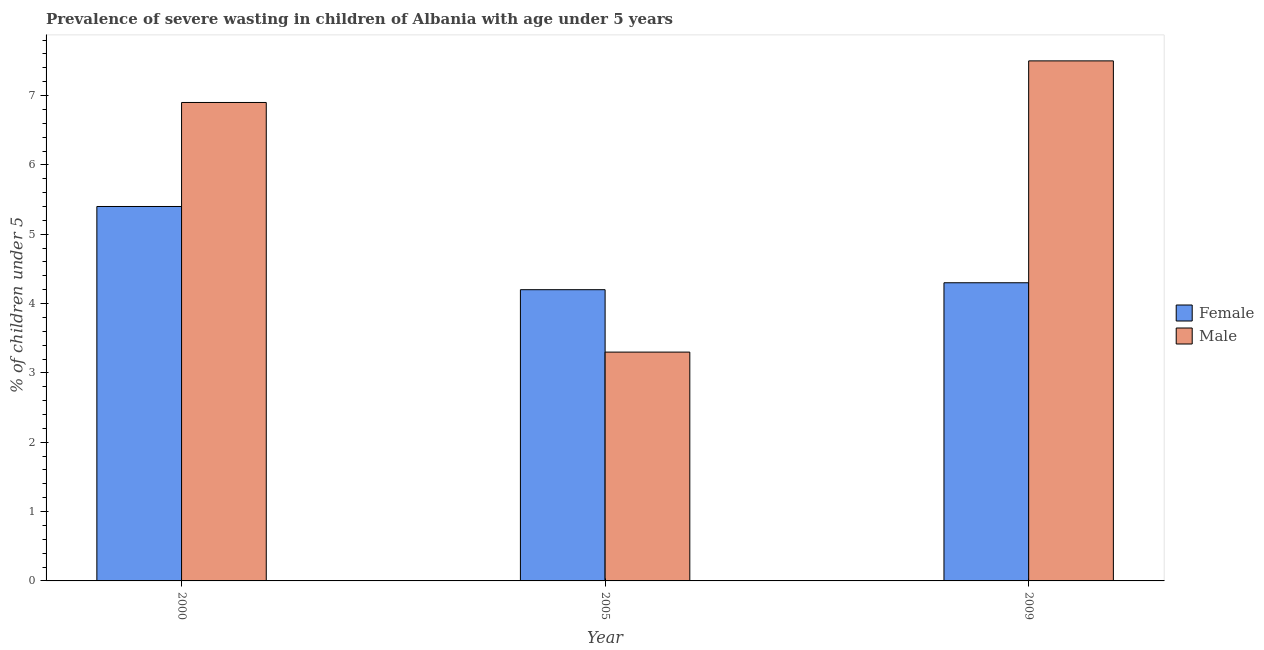How many different coloured bars are there?
Your response must be concise. 2. How many groups of bars are there?
Provide a short and direct response. 3. What is the label of the 1st group of bars from the left?
Your response must be concise. 2000. What is the percentage of undernourished female children in 2005?
Provide a succinct answer. 4.2. Across all years, what is the maximum percentage of undernourished female children?
Your response must be concise. 5.4. Across all years, what is the minimum percentage of undernourished male children?
Your response must be concise. 3.3. In which year was the percentage of undernourished male children maximum?
Your response must be concise. 2009. In which year was the percentage of undernourished male children minimum?
Keep it short and to the point. 2005. What is the total percentage of undernourished male children in the graph?
Your answer should be very brief. 17.7. What is the difference between the percentage of undernourished male children in 2000 and that in 2005?
Make the answer very short. 3.6. What is the difference between the percentage of undernourished male children in 2009 and the percentage of undernourished female children in 2005?
Your answer should be very brief. 4.2. What is the average percentage of undernourished male children per year?
Your answer should be very brief. 5.9. What is the ratio of the percentage of undernourished female children in 2000 to that in 2005?
Provide a succinct answer. 1.29. Is the percentage of undernourished female children in 2000 less than that in 2009?
Your answer should be compact. No. Is the difference between the percentage of undernourished female children in 2000 and 2005 greater than the difference between the percentage of undernourished male children in 2000 and 2005?
Offer a terse response. No. What is the difference between the highest and the second highest percentage of undernourished female children?
Provide a succinct answer. 1.1. What is the difference between the highest and the lowest percentage of undernourished male children?
Keep it short and to the point. 4.2. Is the sum of the percentage of undernourished female children in 2000 and 2005 greater than the maximum percentage of undernourished male children across all years?
Your answer should be compact. Yes. What does the 2nd bar from the left in 2000 represents?
Your response must be concise. Male. What does the 2nd bar from the right in 2000 represents?
Your answer should be very brief. Female. How many bars are there?
Ensure brevity in your answer.  6. Are all the bars in the graph horizontal?
Give a very brief answer. No. How many years are there in the graph?
Keep it short and to the point. 3. What is the difference between two consecutive major ticks on the Y-axis?
Make the answer very short. 1. Are the values on the major ticks of Y-axis written in scientific E-notation?
Your answer should be compact. No. Does the graph contain any zero values?
Offer a very short reply. No. Does the graph contain grids?
Ensure brevity in your answer.  No. Where does the legend appear in the graph?
Keep it short and to the point. Center right. How are the legend labels stacked?
Offer a terse response. Vertical. What is the title of the graph?
Keep it short and to the point. Prevalence of severe wasting in children of Albania with age under 5 years. Does "Resident" appear as one of the legend labels in the graph?
Keep it short and to the point. No. What is the label or title of the Y-axis?
Offer a terse response.  % of children under 5. What is the  % of children under 5 in Female in 2000?
Ensure brevity in your answer.  5.4. What is the  % of children under 5 in Male in 2000?
Offer a very short reply. 6.9. What is the  % of children under 5 in Female in 2005?
Offer a very short reply. 4.2. What is the  % of children under 5 in Male in 2005?
Provide a succinct answer. 3.3. What is the  % of children under 5 in Female in 2009?
Offer a very short reply. 4.3. Across all years, what is the maximum  % of children under 5 of Female?
Make the answer very short. 5.4. Across all years, what is the maximum  % of children under 5 in Male?
Provide a succinct answer. 7.5. Across all years, what is the minimum  % of children under 5 of Female?
Give a very brief answer. 4.2. Across all years, what is the minimum  % of children under 5 in Male?
Your response must be concise. 3.3. What is the total  % of children under 5 of Male in the graph?
Your answer should be very brief. 17.7. What is the difference between the  % of children under 5 of Male in 2000 and that in 2005?
Ensure brevity in your answer.  3.6. What is the difference between the  % of children under 5 of Male in 2000 and that in 2009?
Give a very brief answer. -0.6. What is the difference between the  % of children under 5 in Male in 2005 and that in 2009?
Your answer should be very brief. -4.2. What is the difference between the  % of children under 5 in Female in 2000 and the  % of children under 5 in Male in 2009?
Ensure brevity in your answer.  -2.1. What is the average  % of children under 5 of Female per year?
Provide a succinct answer. 4.63. In the year 2000, what is the difference between the  % of children under 5 in Female and  % of children under 5 in Male?
Offer a very short reply. -1.5. In the year 2005, what is the difference between the  % of children under 5 of Female and  % of children under 5 of Male?
Your answer should be very brief. 0.9. What is the ratio of the  % of children under 5 of Female in 2000 to that in 2005?
Offer a terse response. 1.29. What is the ratio of the  % of children under 5 of Male in 2000 to that in 2005?
Your response must be concise. 2.09. What is the ratio of the  % of children under 5 in Female in 2000 to that in 2009?
Keep it short and to the point. 1.26. What is the ratio of the  % of children under 5 of Female in 2005 to that in 2009?
Keep it short and to the point. 0.98. What is the ratio of the  % of children under 5 of Male in 2005 to that in 2009?
Give a very brief answer. 0.44. What is the difference between the highest and the second highest  % of children under 5 of Male?
Give a very brief answer. 0.6. 